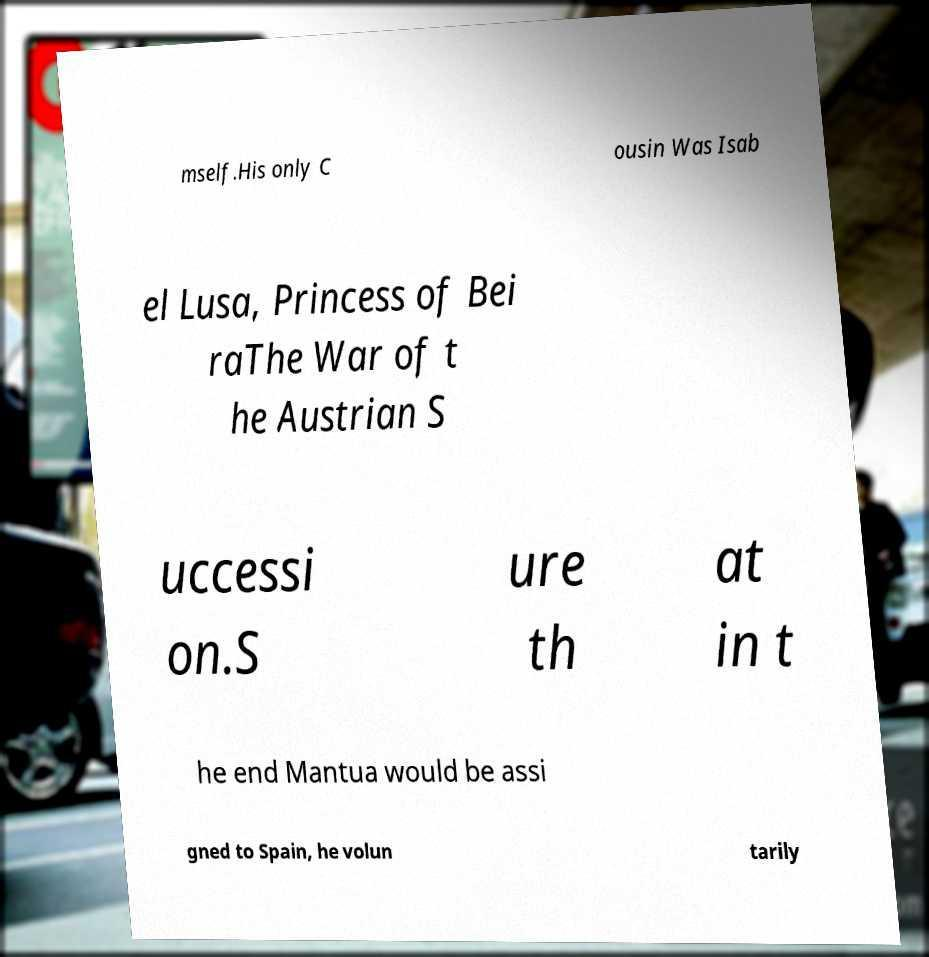Could you assist in decoding the text presented in this image and type it out clearly? mself.His only C ousin Was Isab el Lusa, Princess of Bei raThe War of t he Austrian S uccessi on.S ure th at in t he end Mantua would be assi gned to Spain, he volun tarily 